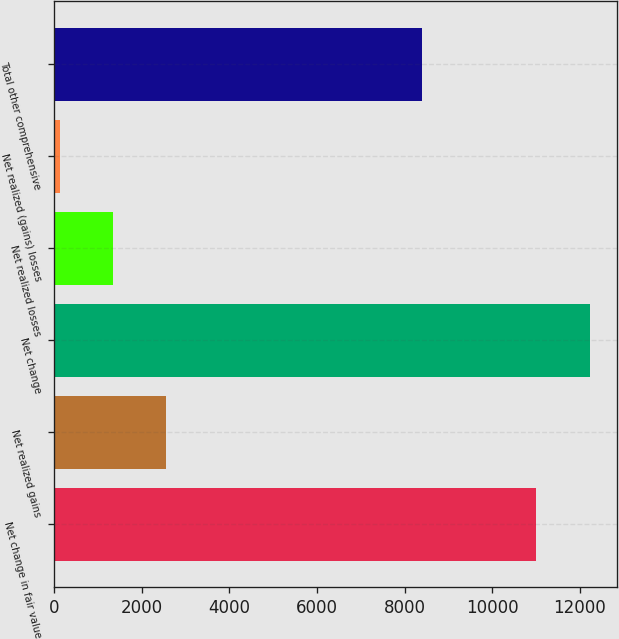Convert chart to OTSL. <chart><loc_0><loc_0><loc_500><loc_500><bar_chart><fcel>Net change in fair value<fcel>Net realized gains<fcel>Net change<fcel>Net realized losses<fcel>Net realized (gains) losses<fcel>Total other comprehensive<nl><fcel>10989<fcel>2558.4<fcel>12240<fcel>1348.2<fcel>138<fcel>8400<nl></chart> 